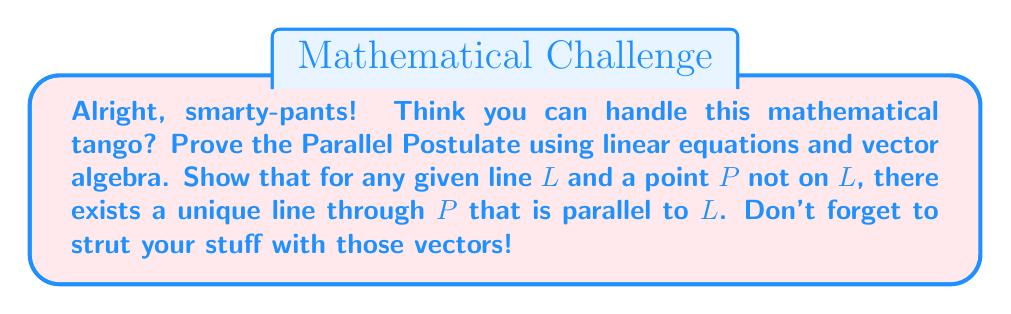Teach me how to tackle this problem. Buckle up, math mavens! Let's dance through this proof:

1) First, let's define our line $L$ using a vector equation:
   $$L: \mathbf{r} = \mathbf{a} + t\mathbf{d}$$
   where $\mathbf{a}$ is a point on $L$, $\mathbf{d}$ is a direction vector, and $t$ is a parameter.

2) Now, let's waltz over to our point $P$, not on $L$. We can represent it as a position vector $\mathbf{p}$.

3) To find a line through $P$ parallel to $L$, we need a vector equation in the form:
   $$\mathbf{r} = \mathbf{p} + s\mathbf{d}$$
   where $s$ is a new parameter. Notice we're using the same direction vector $\mathbf{d}$.

4) Here comes the fancy footwork! For these lines to be distinct, we must show:
   $$\mathbf{p} \neq \mathbf{a} + t\mathbf{d}$$ for any value of $t$.

5) If they were equal, we'd have:
   $$\mathbf{p} - \mathbf{a} = t\mathbf{d}$$

6) But this equation has no solution because $P$ is not on $L$. Therefore, our new line is distinct from $L$.

7) Now, for the grand finale! To prove uniqueness, assume there's another line through $P$ parallel to $L$:
   $$\mathbf{r} = \mathbf{p} + s\mathbf{d'}$$

8) For this to be parallel to $L$, $\mathbf{d'}$ must be a scalar multiple of $\mathbf{d}$:
   $$\mathbf{d'} = k\mathbf{d}$$

9) Substituting back:
   $$\mathbf{r} = \mathbf{p} + s(k\mathbf{d}) = \mathbf{p} + (sk)\mathbf{d}$$

10) Ta-da! This is the same as our original parallel line equation, just with a different parameter $(sk)$ instead of $s$.

Thus, we've shown that there exists a unique line through $P$ parallel to $L$. The Parallel Postulate stands tall, and so do we! Take a bow, math rockstars!
Answer: Unique parallel line exists: $\mathbf{r} = \mathbf{p} + s\mathbf{d}$ 